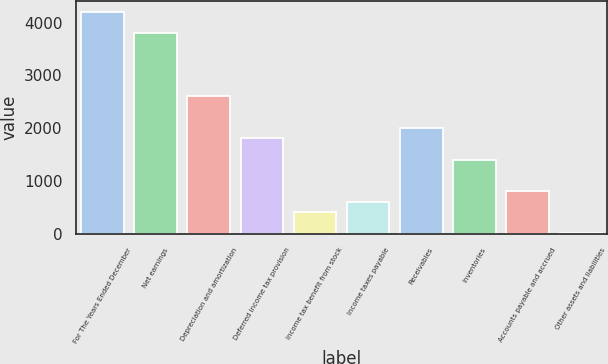<chart> <loc_0><loc_0><loc_500><loc_500><bar_chart><fcel>For The Years Ended December<fcel>Net earnings<fcel>Depreciation and amortization<fcel>Deferred income tax provision<fcel>Income tax benefit from stock<fcel>Income taxes payable<fcel>Receivables<fcel>Inventories<fcel>Accounts payable and accrued<fcel>Other assets and liabilities<nl><fcel>4205.45<fcel>3805.55<fcel>2605.85<fcel>1806.05<fcel>406.4<fcel>606.35<fcel>2006<fcel>1406.15<fcel>806.3<fcel>6.5<nl></chart> 